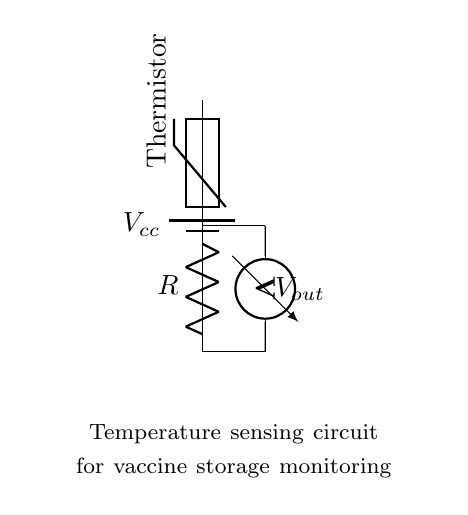What is the voltage source in this circuit? The circuit is powered by a battery, which is marked as Vcc in the diagram. This indicates the voltage source of the circuit.
Answer: Vcc What type of temperature sensor is used in this circuit? The circuit uses a thermistor as the temperature sensor, as indicated by the label next to the thermistor symbol in the diagram.
Answer: Thermistor What does the voltmeter measure in this circuit? The voltmeter in the circuit measures the output voltage across the resistor and thermistor, providing feedback on the voltage related to temperature changes.
Answer: Vout How are the thermistor and resistor connected in this circuit? The thermistor and resistor are connected in series, as they are part of the same pathway from the voltage source to the ground. This is illustrated clearly by the connection lines in the diagram.
Answer: In series What happens to the output voltage when the temperature increases? As the temperature increases, the resistance of the thermistor decreases, leading to an increase in output voltage (Vout) across the voltmeter. This relationship is crucial for monitoring temperature effectively.
Answer: Increases What is the purpose of the resistor in this temperature sensing circuit? The resistor is used to create a voltage divider with the thermistor. This configuration allows for the measurement of changes in voltage as the temperature varies, facilitating accurate monitoring of vaccine storage conditions.
Answer: Voltage divider What is the main application of this circuit? The main application of this circuit is to monitor the storage conditions of vaccines, ensuring that the temperature remains within safe limits for effective preservation.
Answer: Vaccine storage monitoring 